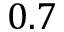<formula> <loc_0><loc_0><loc_500><loc_500>0 . 7</formula> 